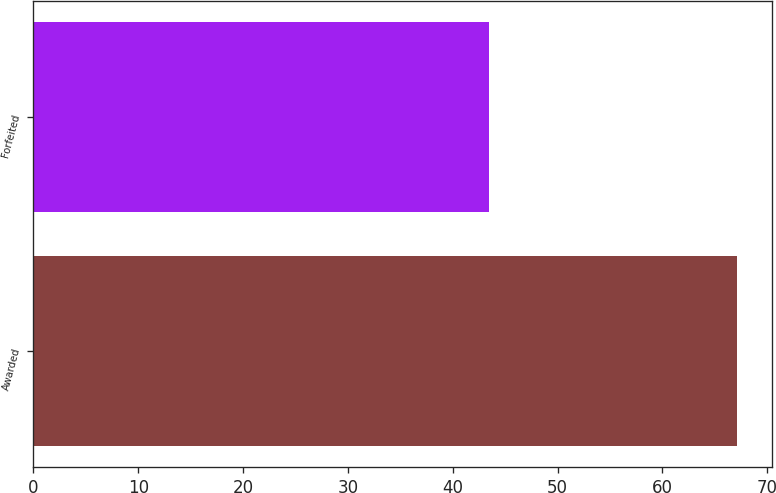<chart> <loc_0><loc_0><loc_500><loc_500><bar_chart><fcel>Awarded<fcel>Forfeited<nl><fcel>67.11<fcel>43.41<nl></chart> 